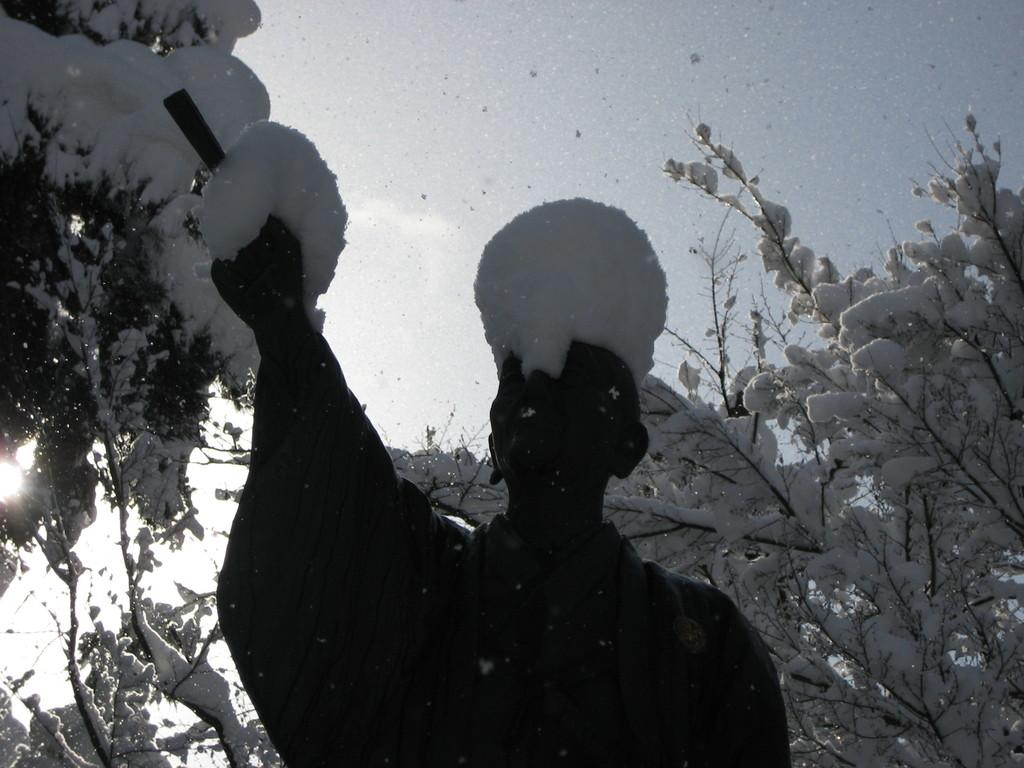What is the main subject of the image? There is a statue of a person in the image. What is covering the statue? The statue has snow on it. What can be seen in the background of the image? There are trees covered with snow in the background. What is visible at the top of the image? The sky is visible at the top of the image. What type of appliance is being used to taste the snow on the statue? There is no appliance present in the image, and the statue is not being tasted. What caption would you give to the image? It is not possible to provide a caption for the image based on the given facts, as captions often involve personal interpretation or context that is not present in the image itself. 